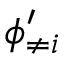<formula> <loc_0><loc_0><loc_500><loc_500>\phi _ { \neq i } ^ { \prime }</formula> 